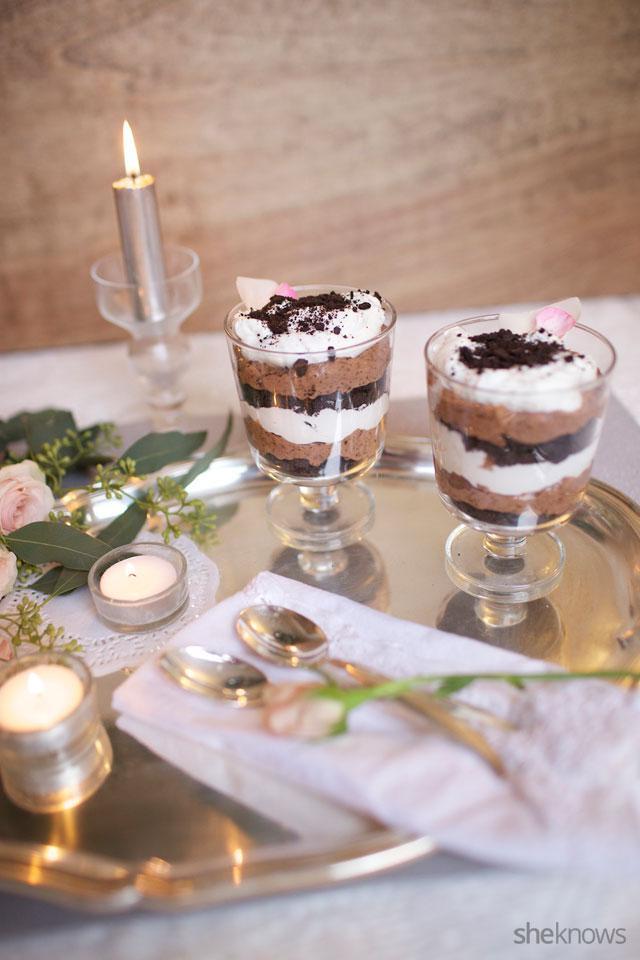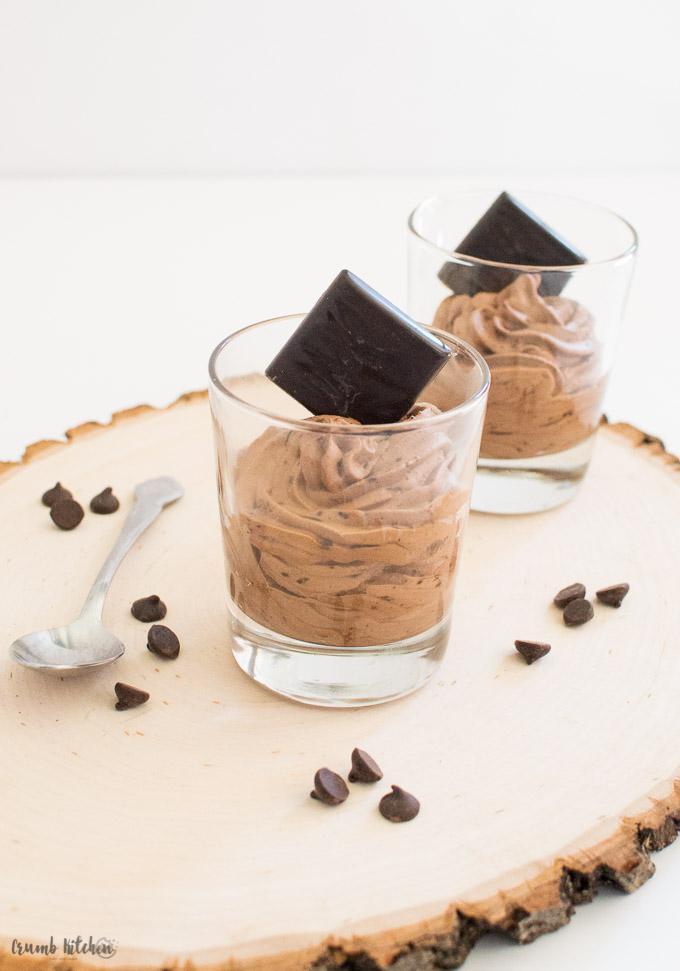The first image is the image on the left, the second image is the image on the right. For the images shown, is this caption "In both pictures on the right side, there are three glasses the contain layers of chocolate and whipped cream topped with cookie crumbles." true? Answer yes or no. No. The first image is the image on the left, the second image is the image on the right. For the images shown, is this caption "# glasses are filed with cream and fruit." true? Answer yes or no. No. 